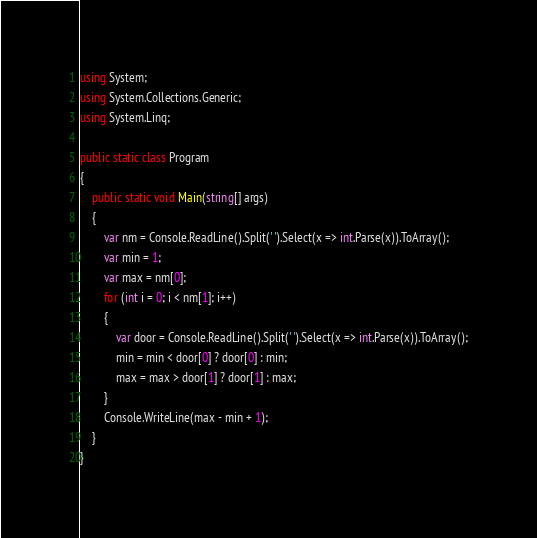Convert code to text. <code><loc_0><loc_0><loc_500><loc_500><_C#_>using System;
using System.Collections.Generic;
using System.Linq;

public static class Program
{
    public static void Main(string[] args)
    {
        var nm = Console.ReadLine().Split(' ').Select(x => int.Parse(x)).ToArray();
        var min = 1;
        var max = nm[0];
        for (int i = 0; i < nm[1]; i++)
        {
            var door = Console.ReadLine().Split(' ').Select(x => int.Parse(x)).ToArray();
            min = min < door[0] ? door[0] : min;
            max = max > door[1] ? door[1] : max;
        }
        Console.WriteLine(max - min + 1);
    }
}</code> 